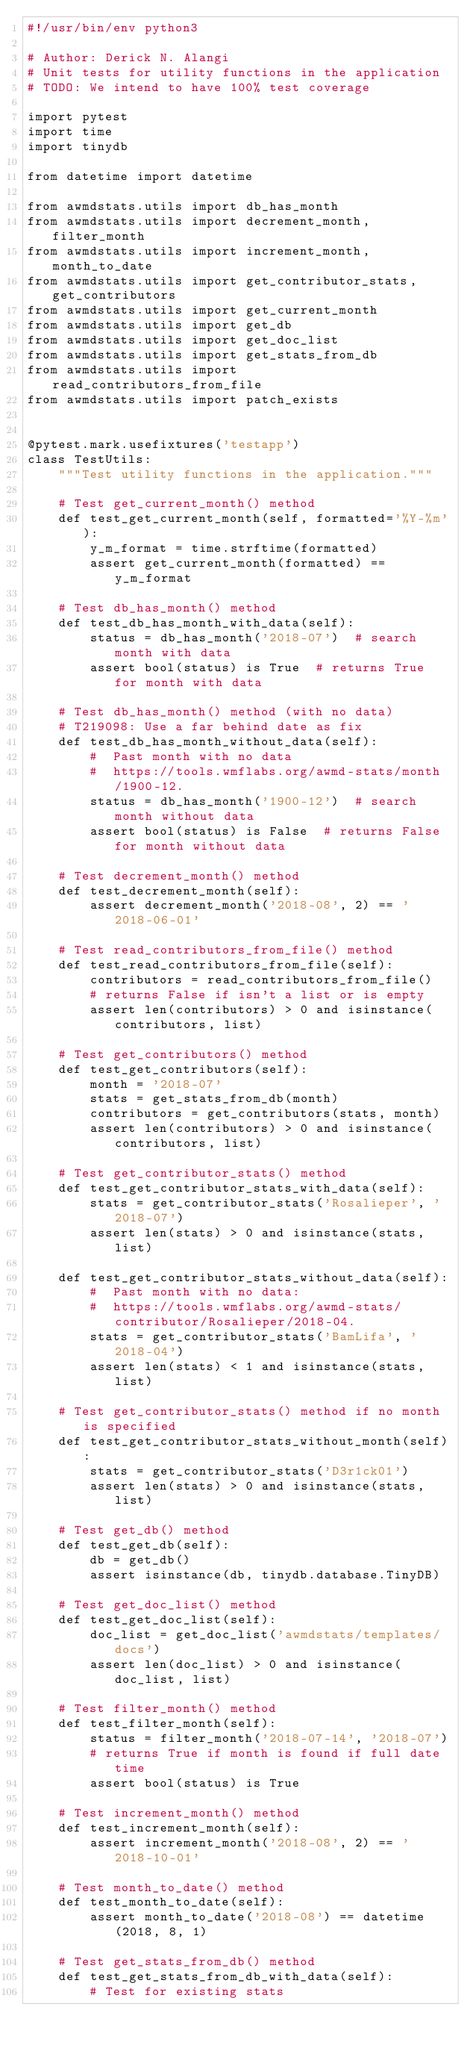Convert code to text. <code><loc_0><loc_0><loc_500><loc_500><_Python_>#!/usr/bin/env python3

# Author: Derick N. Alangi
# Unit tests for utility functions in the application
# TODO: We intend to have 100% test coverage

import pytest
import time
import tinydb

from datetime import datetime

from awmdstats.utils import db_has_month
from awmdstats.utils import decrement_month, filter_month
from awmdstats.utils import increment_month, month_to_date
from awmdstats.utils import get_contributor_stats, get_contributors
from awmdstats.utils import get_current_month
from awmdstats.utils import get_db
from awmdstats.utils import get_doc_list
from awmdstats.utils import get_stats_from_db
from awmdstats.utils import read_contributors_from_file
from awmdstats.utils import patch_exists


@pytest.mark.usefixtures('testapp')
class TestUtils:
    """Test utility functions in the application."""

    # Test get_current_month() method
    def test_get_current_month(self, formatted='%Y-%m'):
        y_m_format = time.strftime(formatted)
        assert get_current_month(formatted) == y_m_format

    # Test db_has_month() method
    def test_db_has_month_with_data(self):
        status = db_has_month('2018-07')  # search month with data
        assert bool(status) is True  # returns True for month with data

    # Test db_has_month() method (with no data)
    # T219098: Use a far behind date as fix
    def test_db_has_month_without_data(self):
        #  Past month with no data
        #  https://tools.wmflabs.org/awmd-stats/month/1900-12.
        status = db_has_month('1900-12')  # search month without data
        assert bool(status) is False  # returns False for month without data

    # Test decrement_month() method
    def test_decrement_month(self):
        assert decrement_month('2018-08', 2) == '2018-06-01'

    # Test read_contributors_from_file() method
    def test_read_contributors_from_file(self):
        contributors = read_contributors_from_file()
        # returns False if isn't a list or is empty
        assert len(contributors) > 0 and isinstance(contributors, list)

    # Test get_contributors() method
    def test_get_contributors(self):
        month = '2018-07'
        stats = get_stats_from_db(month)
        contributors = get_contributors(stats, month)
        assert len(contributors) > 0 and isinstance(contributors, list)

    # Test get_contributor_stats() method
    def test_get_contributor_stats_with_data(self):
        stats = get_contributor_stats('Rosalieper', '2018-07')
        assert len(stats) > 0 and isinstance(stats, list)

    def test_get_contributor_stats_without_data(self):
        #  Past month with no data:
        #  https://tools.wmflabs.org/awmd-stats/contributor/Rosalieper/2018-04.
        stats = get_contributor_stats('BamLifa', '2018-04')
        assert len(stats) < 1 and isinstance(stats, list)

    # Test get_contributor_stats() method if no month is specified
    def test_get_contributor_stats_without_month(self):
        stats = get_contributor_stats('D3r1ck01')
        assert len(stats) > 0 and isinstance(stats, list)

    # Test get_db() method
    def test_get_db(self):
        db = get_db()
        assert isinstance(db, tinydb.database.TinyDB)

    # Test get_doc_list() method
    def test_get_doc_list(self):
        doc_list = get_doc_list('awmdstats/templates/docs')
        assert len(doc_list) > 0 and isinstance(doc_list, list)

    # Test filter_month() method
    def test_filter_month(self):
        status = filter_month('2018-07-14', '2018-07')
        # returns True if month is found if full date time
        assert bool(status) is True

    # Test increment_month() method
    def test_increment_month(self):
        assert increment_month('2018-08', 2) == '2018-10-01'

    # Test month_to_date() method
    def test_month_to_date(self):
        assert month_to_date('2018-08') == datetime(2018, 8, 1)

    # Test get_stats_from_db() method
    def test_get_stats_from_db_with_data(self):
        # Test for existing stats</code> 